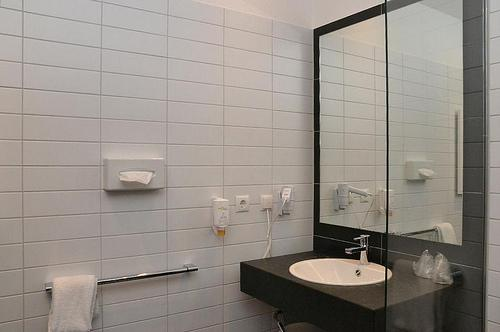Question: who is in the bathroom?
Choices:
A. No one.
B. The woman.
C. The dog.
D. The man.
Answer with the letter. Answer: A Question: why is the towel on the bar?
Choices:
A. For decoration.
B. To dry a person's entire body.
C. To clean.
D. To dry a person's hands.
Answer with the letter. Answer: D Question: what can be seen in the mirror?
Choices:
A. Reflections.
B. A man.
C. A woman.
D. Nothing.
Answer with the letter. Answer: A 